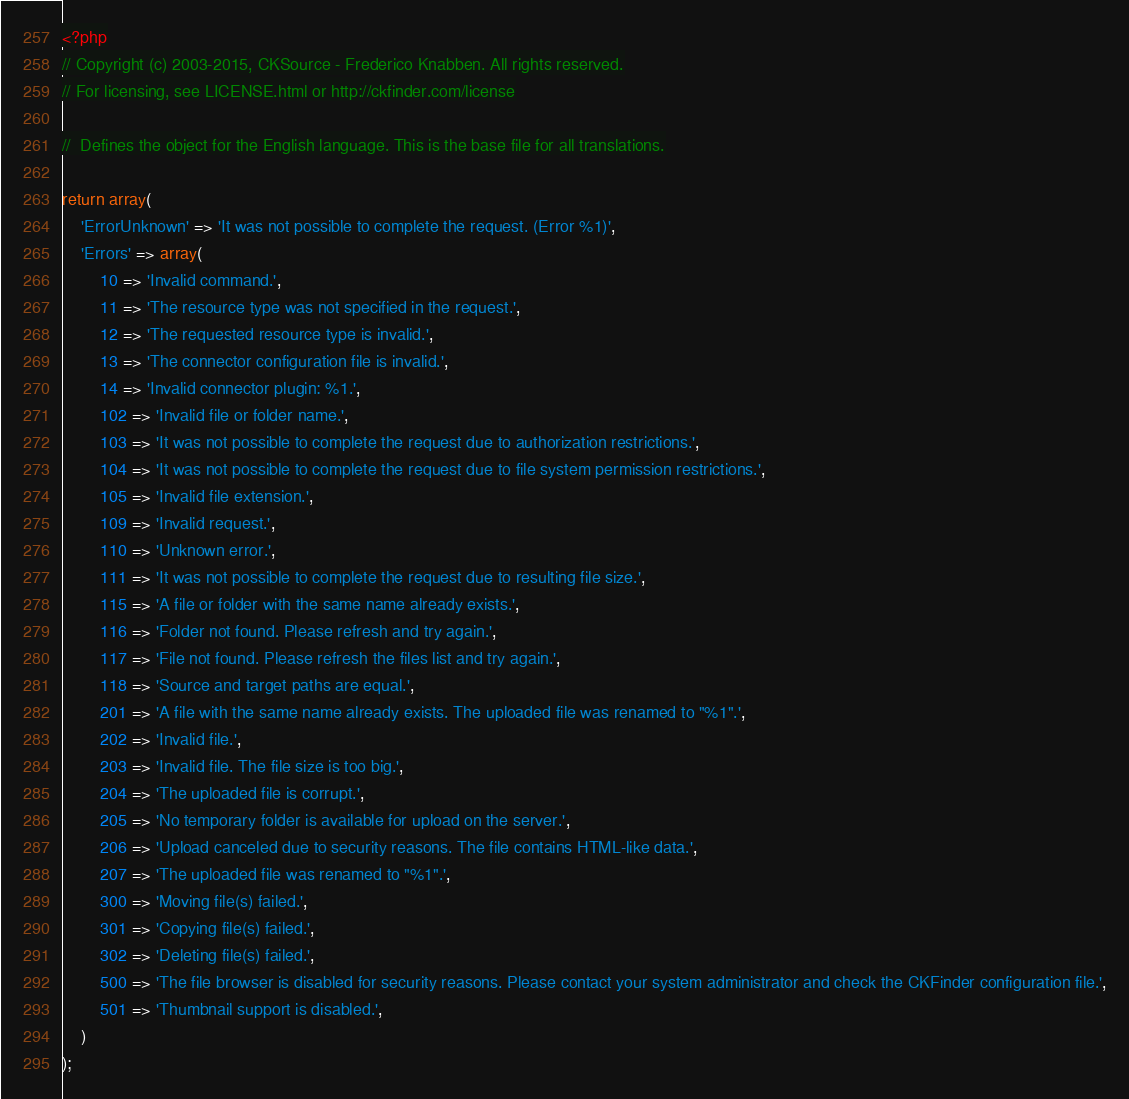<code> <loc_0><loc_0><loc_500><loc_500><_PHP_><?php
// Copyright (c) 2003-2015, CKSource - Frederico Knabben. All rights reserved.
// For licensing, see LICENSE.html or http://ckfinder.com/license

//  Defines the object for the English language. This is the base file for all translations.

return array(
    'ErrorUnknown' => 'It was not possible to complete the request. (Error %1)',
    'Errors' => array(
        10 => 'Invalid command.',
        11 => 'The resource type was not specified in the request.',
        12 => 'The requested resource type is invalid.',
        13 => 'The connector configuration file is invalid.',
        14 => 'Invalid connector plugin: %1.',
        102 => 'Invalid file or folder name.',
        103 => 'It was not possible to complete the request due to authorization restrictions.',
        104 => 'It was not possible to complete the request due to file system permission restrictions.',
        105 => 'Invalid file extension.',
        109 => 'Invalid request.',
        110 => 'Unknown error.',
        111 => 'It was not possible to complete the request due to resulting file size.',
        115 => 'A file or folder with the same name already exists.',
        116 => 'Folder not found. Please refresh and try again.',
        117 => 'File not found. Please refresh the files list and try again.',
        118 => 'Source and target paths are equal.',
        201 => 'A file with the same name already exists. The uploaded file was renamed to "%1".',
        202 => 'Invalid file.',
        203 => 'Invalid file. The file size is too big.',
        204 => 'The uploaded file is corrupt.',
        205 => 'No temporary folder is available for upload on the server.',
        206 => 'Upload canceled due to security reasons. The file contains HTML-like data.',
        207 => 'The uploaded file was renamed to "%1".',
        300 => 'Moving file(s) failed.',
        301 => 'Copying file(s) failed.',
        302 => 'Deleting file(s) failed.',
        500 => 'The file browser is disabled for security reasons. Please contact your system administrator and check the CKFinder configuration file.',
        501 => 'Thumbnail support is disabled.',
    )
);
</code> 